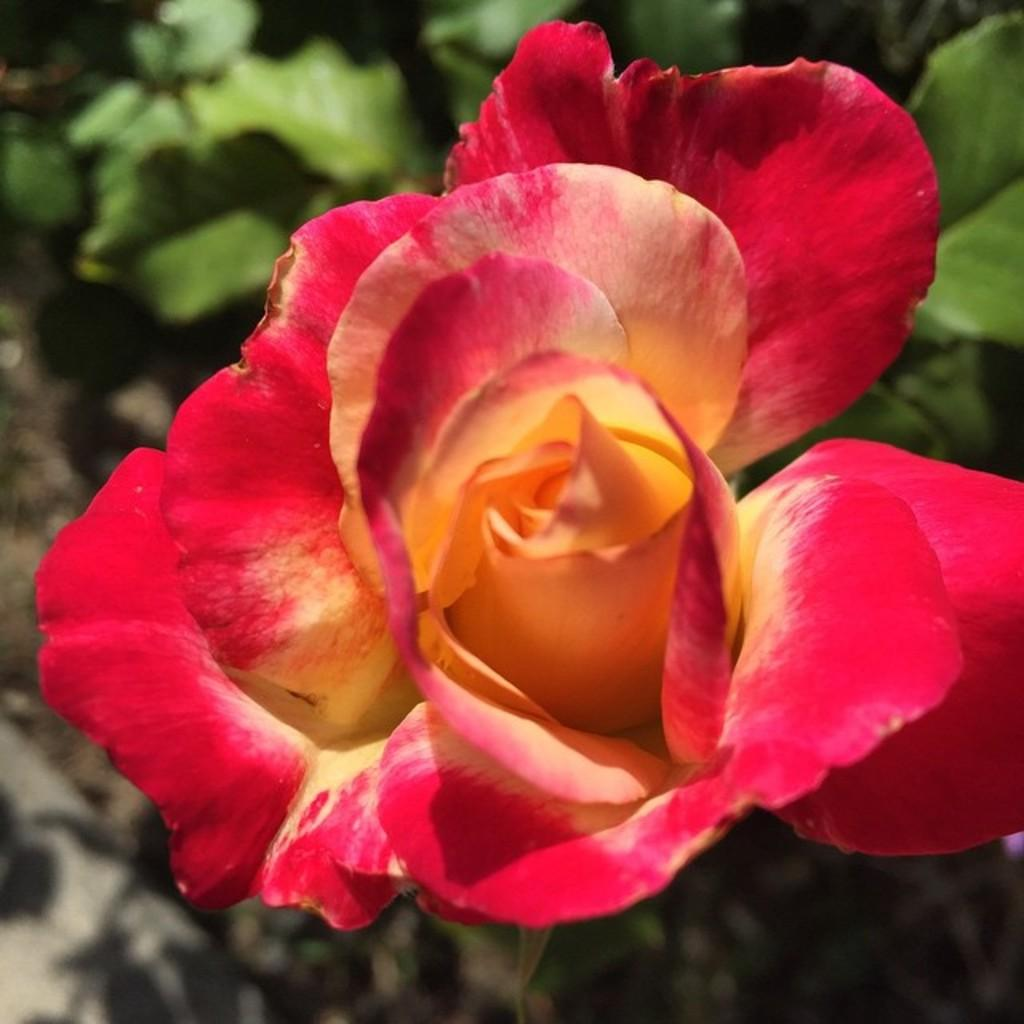What is the main subject in the center of the image? There is a rose in the center of the image. What can be seen in the background of the image? There are leaves in the background of the image. What type of agreement is being signed in the image? There is no agreement or signing activity present in the image; it features a rose and leaves. What shape is the sun in the image? There is no sun present in the image; it features a rose and leaves. 